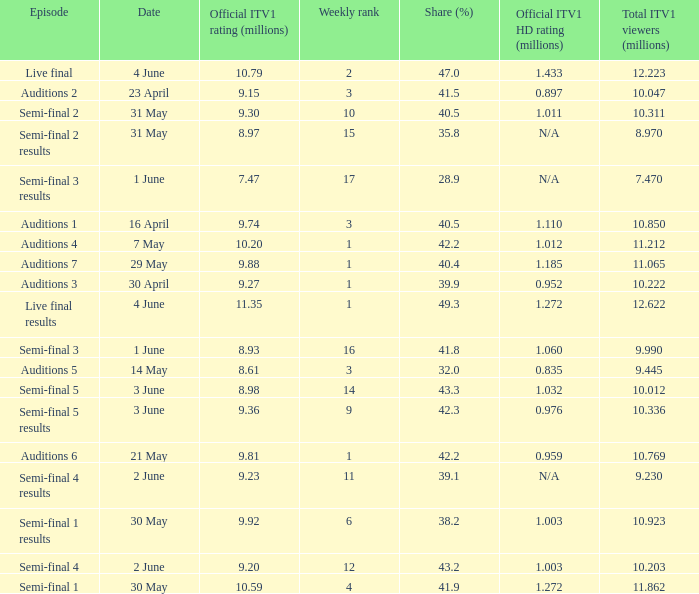What was the official ITV1 rating in millions of the Live Final Results episode? 11.35. 